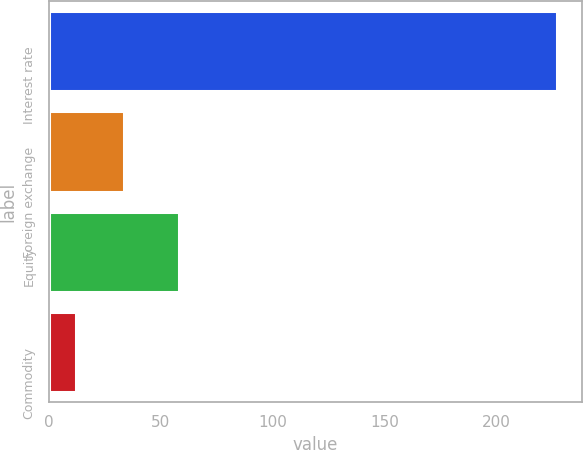<chart> <loc_0><loc_0><loc_500><loc_500><bar_chart><fcel>Interest rate<fcel>Foreign exchange<fcel>Equity<fcel>Commodity<nl><fcel>227<fcel>33.5<fcel>58<fcel>12<nl></chart> 